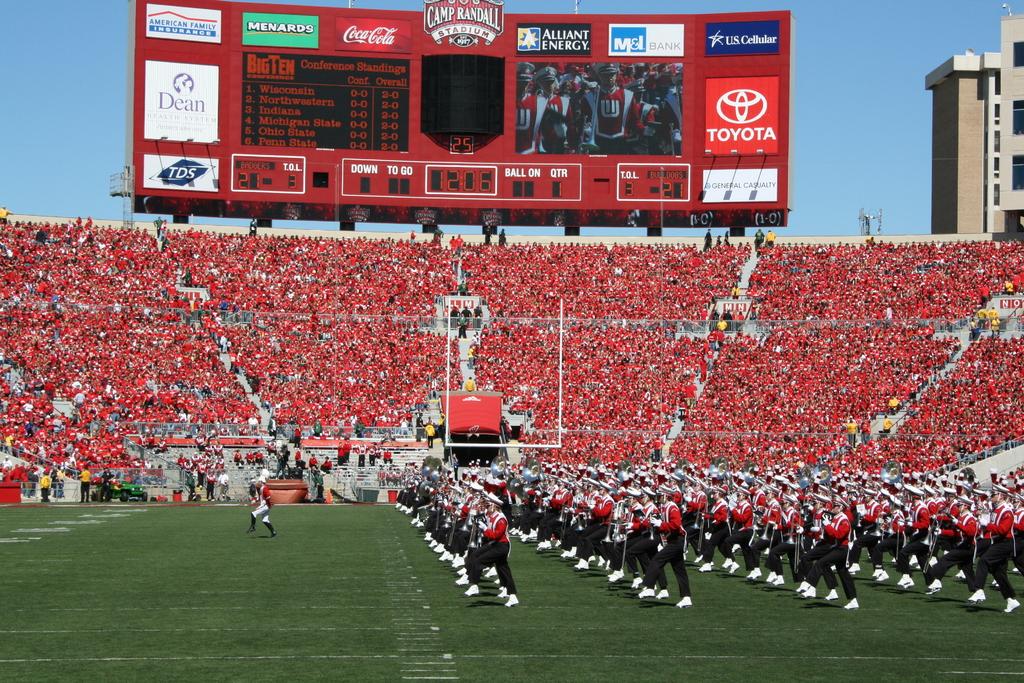What car sponsors this event?
Your answer should be very brief. Toyota. What soft drink company sponsors this event?
Make the answer very short. Coca cola. 